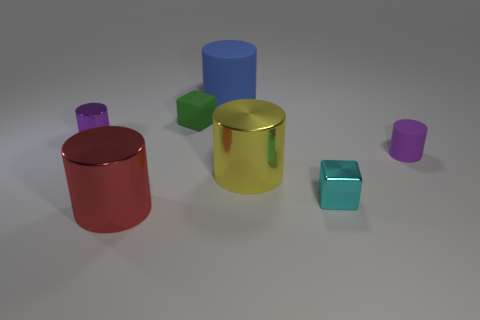What can you infer about the material of the objects based on their appearance? The objects exhibit varying degrees of glossiness, suggesting they are made of different materials. For instance, the yellow cylinder has a reflective metallic appearance, while the cubes have a matte finish, hinting at a possibly plastic or non-metallic material. 